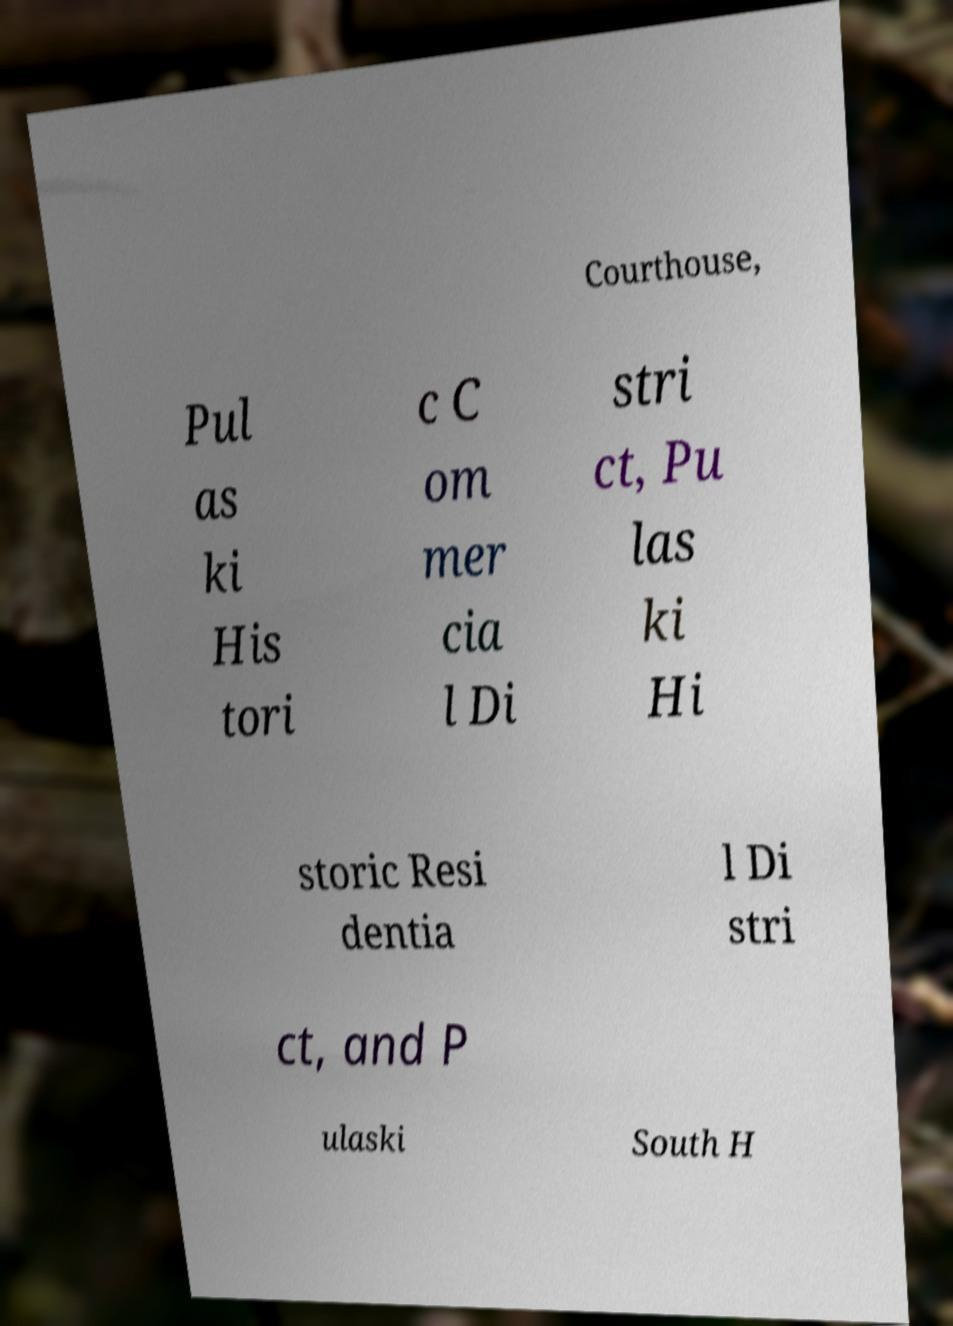Could you assist in decoding the text presented in this image and type it out clearly? Courthouse, Pul as ki His tori c C om mer cia l Di stri ct, Pu las ki Hi storic Resi dentia l Di stri ct, and P ulaski South H 